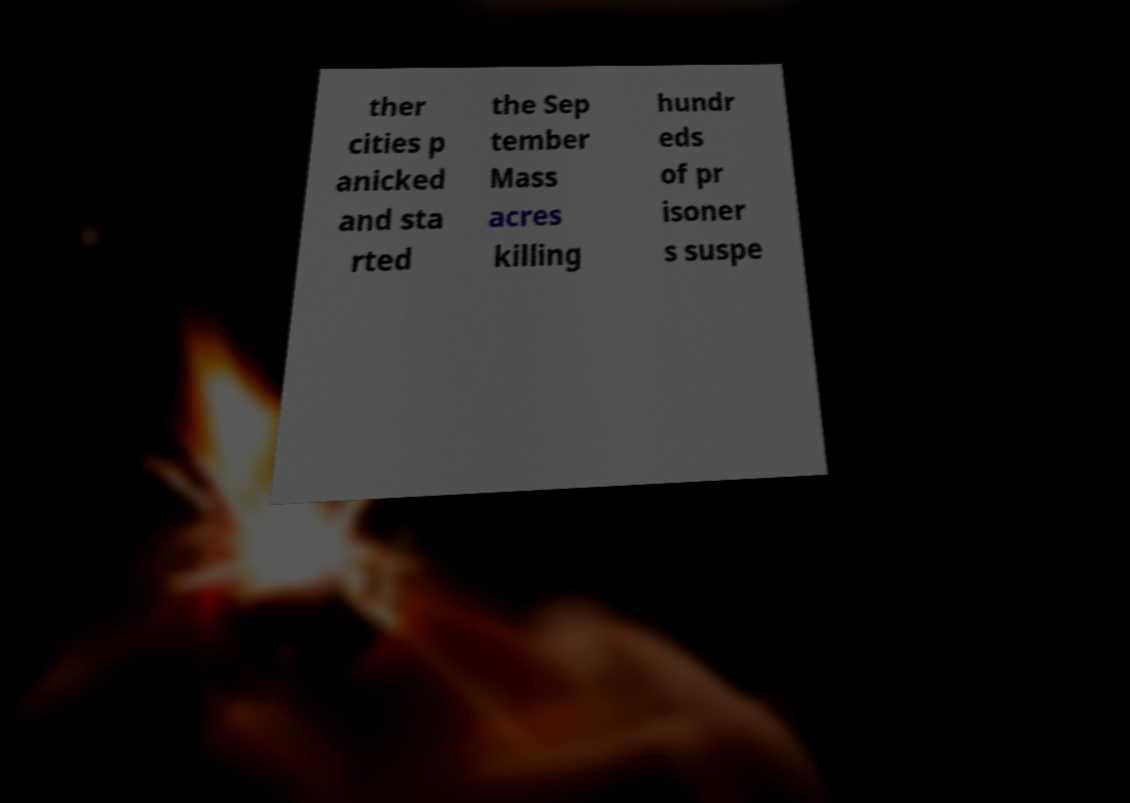Could you extract and type out the text from this image? ther cities p anicked and sta rted the Sep tember Mass acres killing hundr eds of pr isoner s suspe 